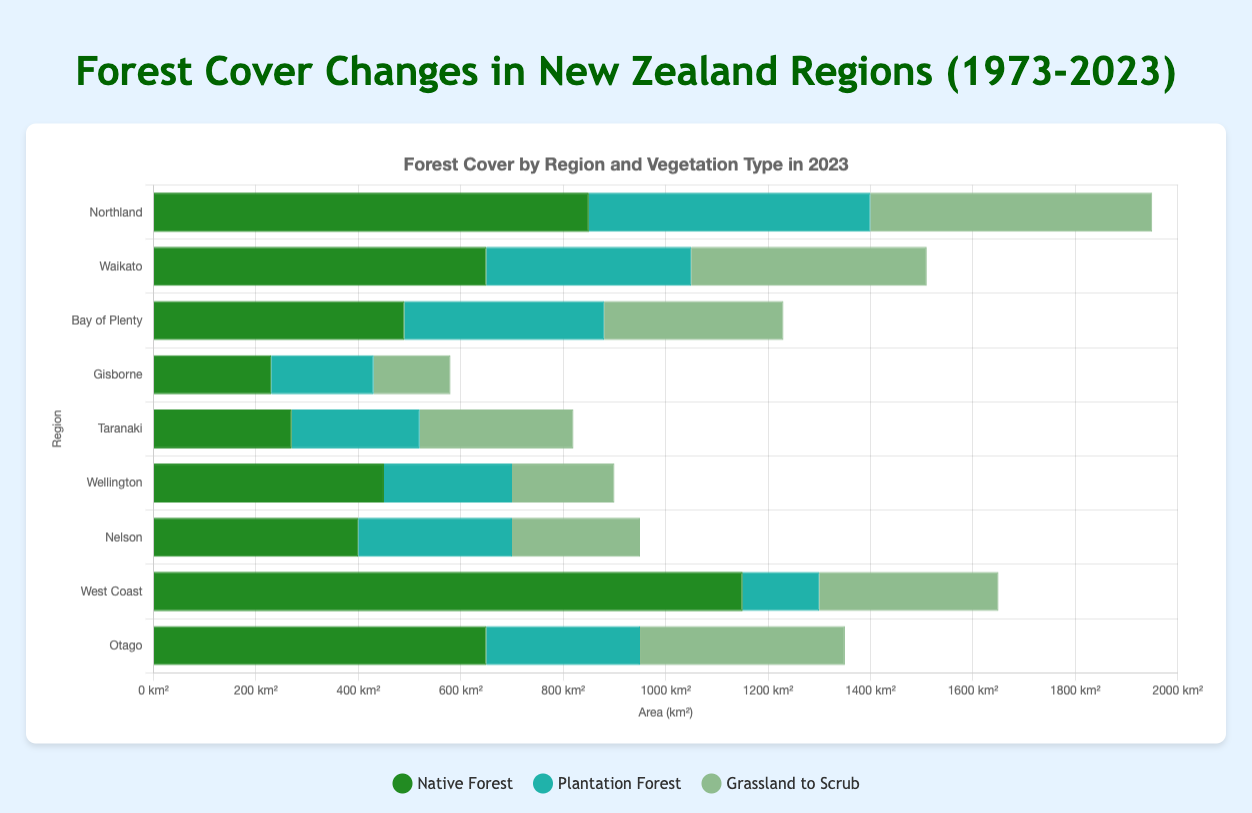What is the total area covered by Native Forest across all regions in 2023? Sum up the Native Forest areas for each region: (850 + 650 + 490 + 230 + 270 + 450 + 400 + 1150 + 650) = 5140 km²
Answer: 5140 km² Which region has the highest area of Plantation Forest in 2023? Compare the Plantation Forest areas for each region: Northland (550), Waikato (400), Bay of Plenty (390), Gisborne (200), Taranaki (250), Wellington (250), Nelson (300), West Coast (150), Otago (300). Northland has the highest area.
Answer: Northland What is the difference in Native Forest area between West Coast and Wellington in 2023? Calculate the difference: West Coast (1150) - Wellington (450) = 700 km²
Answer: 700 km² How does the area of Grassland to Scrub in Northland compare to that in Otago in 2023? Compare the areas: Northland (550) and Otago (400). Northland has more Grassland to Scrub area than Otago.
Answer: Northland has more What percentage of total forest in Waikato is Plantation Forest in 2023? Total forest in Waikato = Native Forest + Plantation Forest + Grassland to Scrub = 650 + 400 + 460 = 1510. Percentage = (400 / 1510) * 100 = 26.49%
Answer: 26.49% How has the area of Native Forest in Northland changed from 1973 to 2023? Subtract the area in 2023 from 1973: 1200 (1973) - 850 (2023) = 350 km² decrease
Answer: 350 km² decrease Which vegetation type shows the least variation in area across all regions in 2023? Compare the range (max-min) for each type: Native Forest (1150-230=920), Plantation Forest (550-150=400), Grassland to Scrub (550-150=400). Both Plantation Forest and Grassland to Scrub have the same least variation.
Answer: Plantation Forest and Grassland to Scrub In 2023, which region has the smallest total forest area and what is it? Calculate total forest for each region and identify the smallest: Gisborne (230+200+150=580 km²), then compare with other totals. Gisborne has the smallest area.
Answer: Gisborne with 580 km² What is the sum of all vegetation types in Nelson in 2023? Add the areas: Native Forest (400) + Plantation Forest (300) + Grassland to Scrub (250) = 950 km²
Answer: 950 km² 